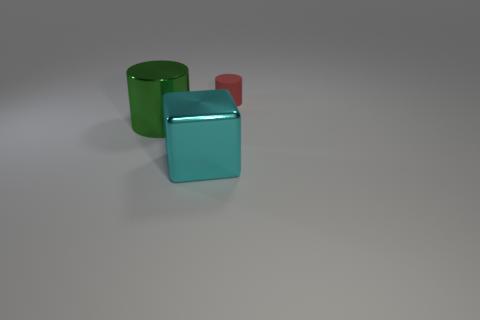Subtract all red cylinders. How many cylinders are left? 1 Add 1 cyan objects. How many objects exist? 4 Subtract all blocks. How many objects are left? 2 Subtract all brown cylinders. Subtract all purple blocks. How many cylinders are left? 2 Subtract all red spheres. How many yellow blocks are left? 0 Subtract all red cylinders. Subtract all red blocks. How many objects are left? 2 Add 1 cyan things. How many cyan things are left? 2 Add 2 green metal cylinders. How many green metal cylinders exist? 3 Subtract 0 brown cubes. How many objects are left? 3 Subtract 1 blocks. How many blocks are left? 0 